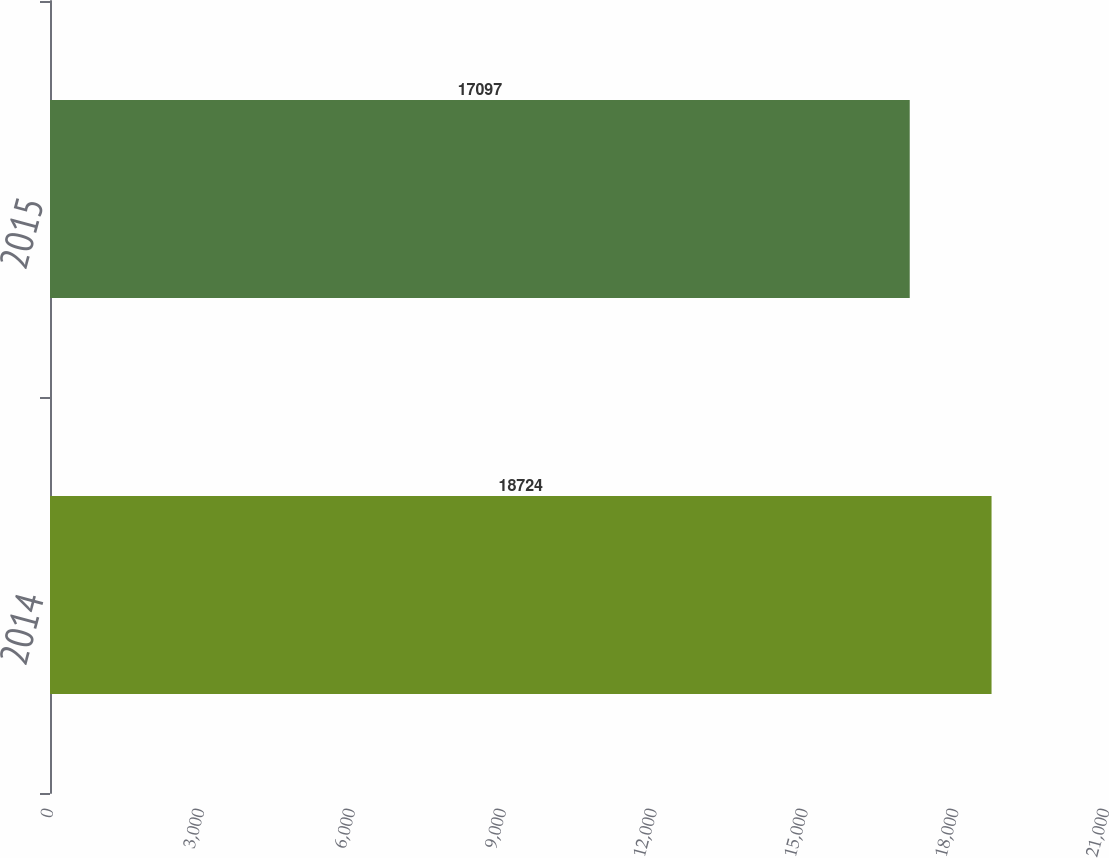Convert chart to OTSL. <chart><loc_0><loc_0><loc_500><loc_500><bar_chart><fcel>2014<fcel>2015<nl><fcel>18724<fcel>17097<nl></chart> 